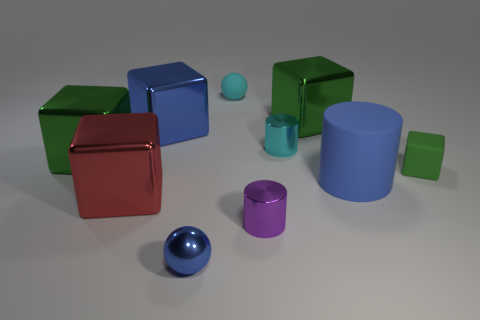There is a large green block behind the cyan metallic thing; are there any metal blocks that are to the left of it?
Offer a terse response. Yes. There is a tiny thing that is the same shape as the big blue metal object; what is its material?
Provide a succinct answer. Rubber. There is a metallic cylinder behind the tiny purple thing; how many big green metallic blocks are in front of it?
Ensure brevity in your answer.  1. What number of things are green metal cylinders or big shiny cubes left of the tiny shiny sphere?
Your answer should be very brief. 3. What is the small ball in front of the large green thing that is in front of the green shiny cube that is to the right of the tiny cyan rubber ball made of?
Provide a succinct answer. Metal. There is a cyan object that is made of the same material as the small cube; what is its size?
Your response must be concise. Small. What color is the thing behind the big green thing behind the cyan cylinder?
Provide a short and direct response. Cyan. How many large blue cylinders have the same material as the tiny purple thing?
Offer a very short reply. 0. How many matte objects are either small cyan spheres or blue spheres?
Your answer should be very brief. 1. There is a purple object that is the same size as the cyan sphere; what material is it?
Ensure brevity in your answer.  Metal. 